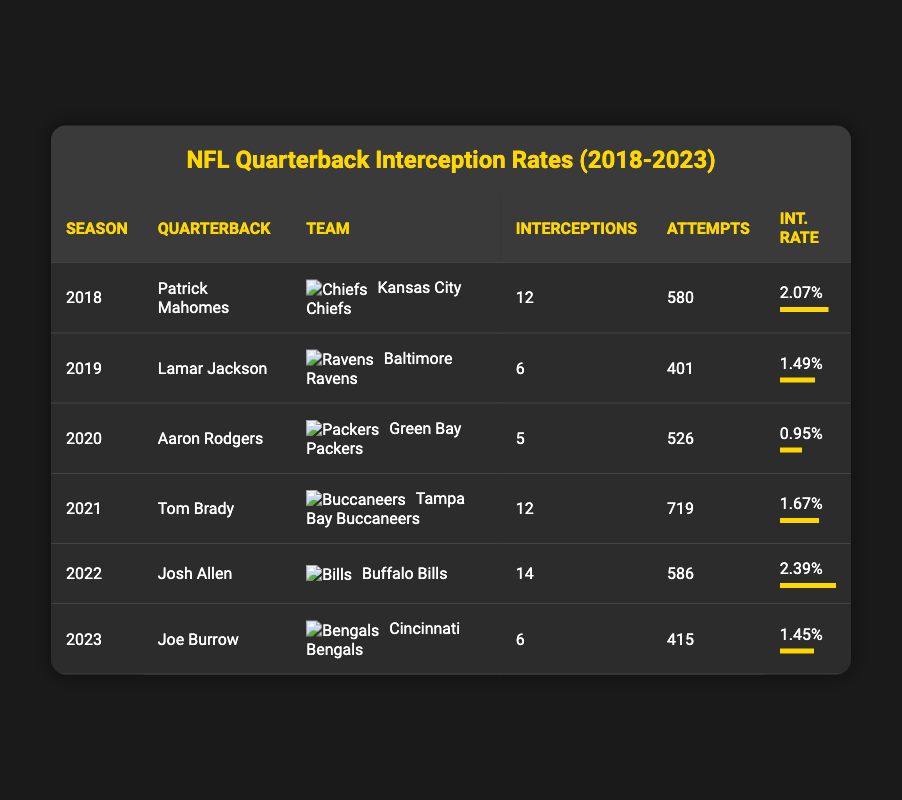What was the interception rate for Patrick Mahomes in 2018? The table lists Patrick Mahomes under the 2018 season with an interception rate of 2.07%.
Answer: 2.07% Who had the highest interception rate in 2022? By examining the interception rates listed for each quarterback in 2022, Josh Allen is identified as having the highest interception rate of 2.39%.
Answer: Josh Allen What is the total number of interceptions thrown by Tom Brady and Aaron Rodgers combined? Tom Brady had 12 interceptions in 2021 and Aaron Rodgers had 5 interceptions in 2020. Adding these two together gives 12 + 5 = 17.
Answer: 17 Is it true that Joe Burrow had a lower interception rate in 2023 than Lamar Jackson in 2019? Joe Burrow's interception rate in 2023 is 1.45%, while Lamar Jackson's interception rate in 2019 is 1.49%. Since 1.45% is less than 1.49%, the statement is true.
Answer: Yes What is the average interception rate across the quarterbacks listed for the five seasons? The interception rates for each quarterback are: 2.07%, 1.49%, 0.95%, 1.67%, 2.39%, and 1.45%. To find the average, we sum these rates: 2.07 + 1.49 + 0.95 + 1.67 + 2.39 + 1.45 = 9.02. Dividing by 6 gives 9.02 / 6 = 1.50 (rounded to two decimal places).
Answer: 1.50 Who attempted the most passes in a season among the quarterbacks listed? By checking the attempts for each quarterback in the table, Tom Brady attempted the most passes in 2021 with 719 attempts.
Answer: 719 